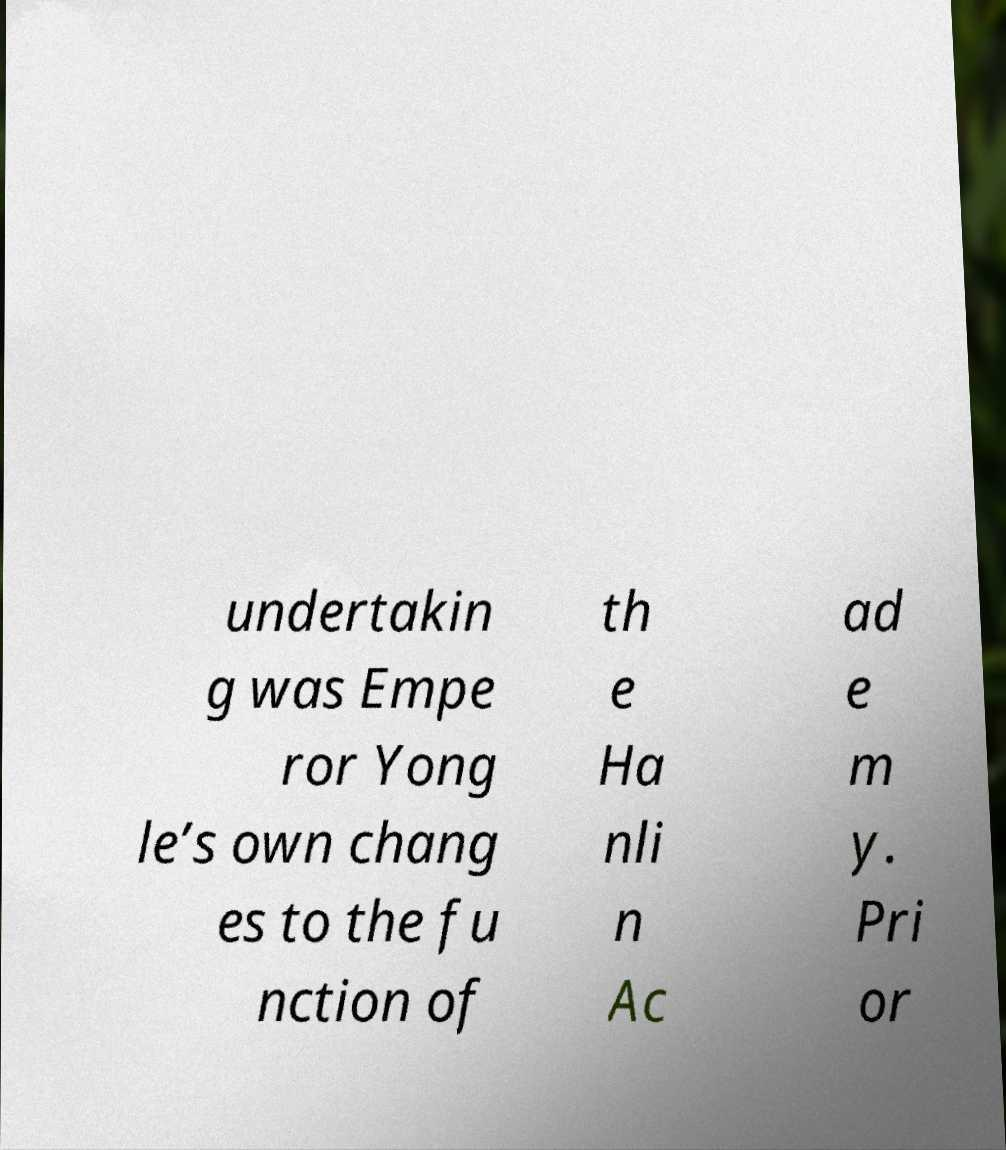Please read and relay the text visible in this image. What does it say? undertakin g was Empe ror Yong le’s own chang es to the fu nction of th e Ha nli n Ac ad e m y. Pri or 